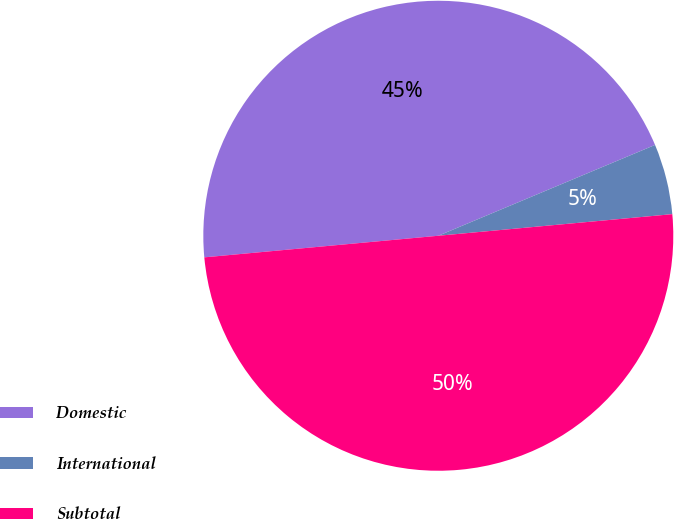<chart> <loc_0><loc_0><loc_500><loc_500><pie_chart><fcel>Domestic<fcel>International<fcel>Subtotal<nl><fcel>45.15%<fcel>4.85%<fcel>50.0%<nl></chart> 